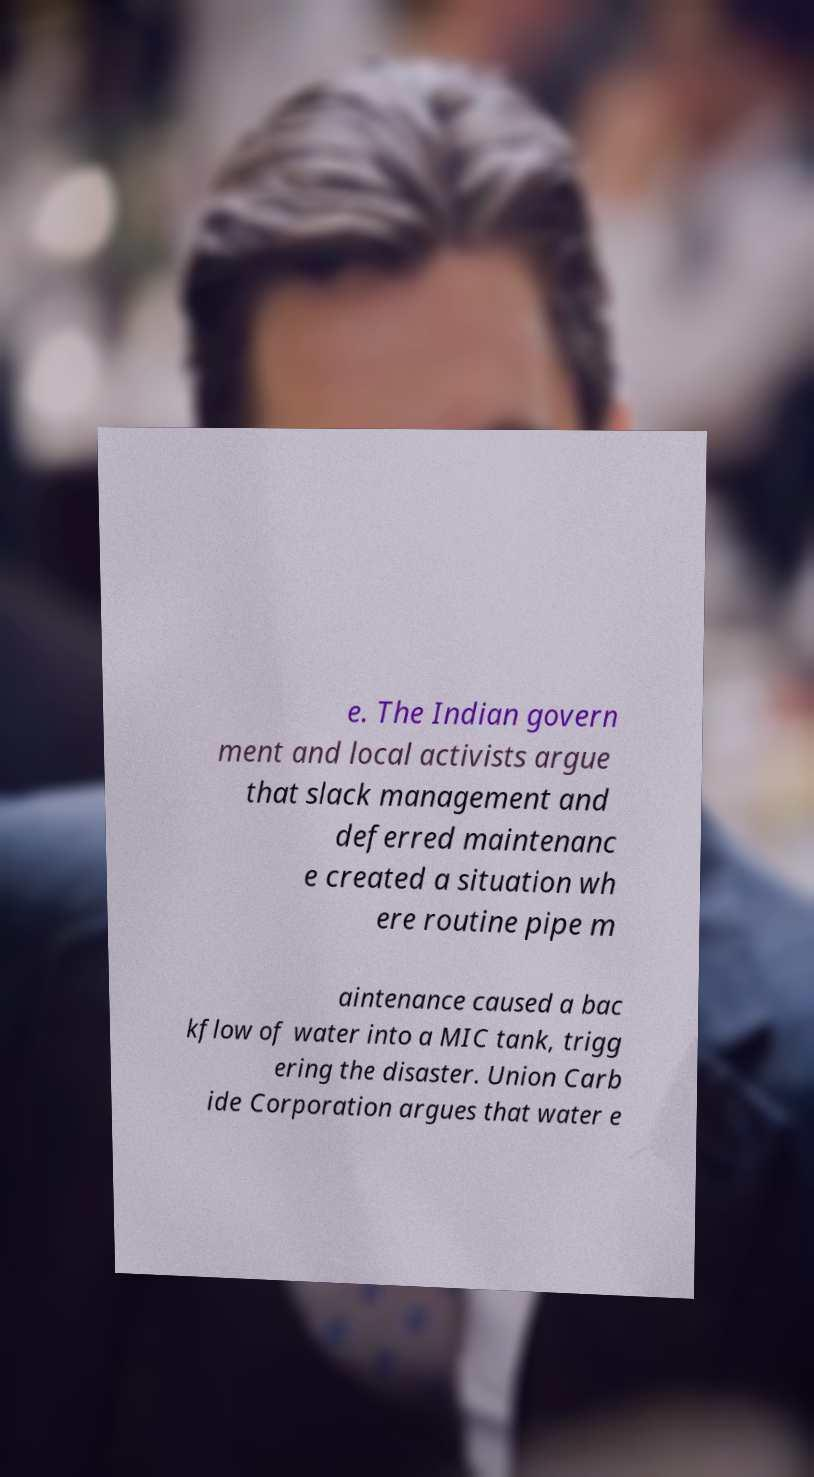For documentation purposes, I need the text within this image transcribed. Could you provide that? e. The Indian govern ment and local activists argue that slack management and deferred maintenanc e created a situation wh ere routine pipe m aintenance caused a bac kflow of water into a MIC tank, trigg ering the disaster. Union Carb ide Corporation argues that water e 